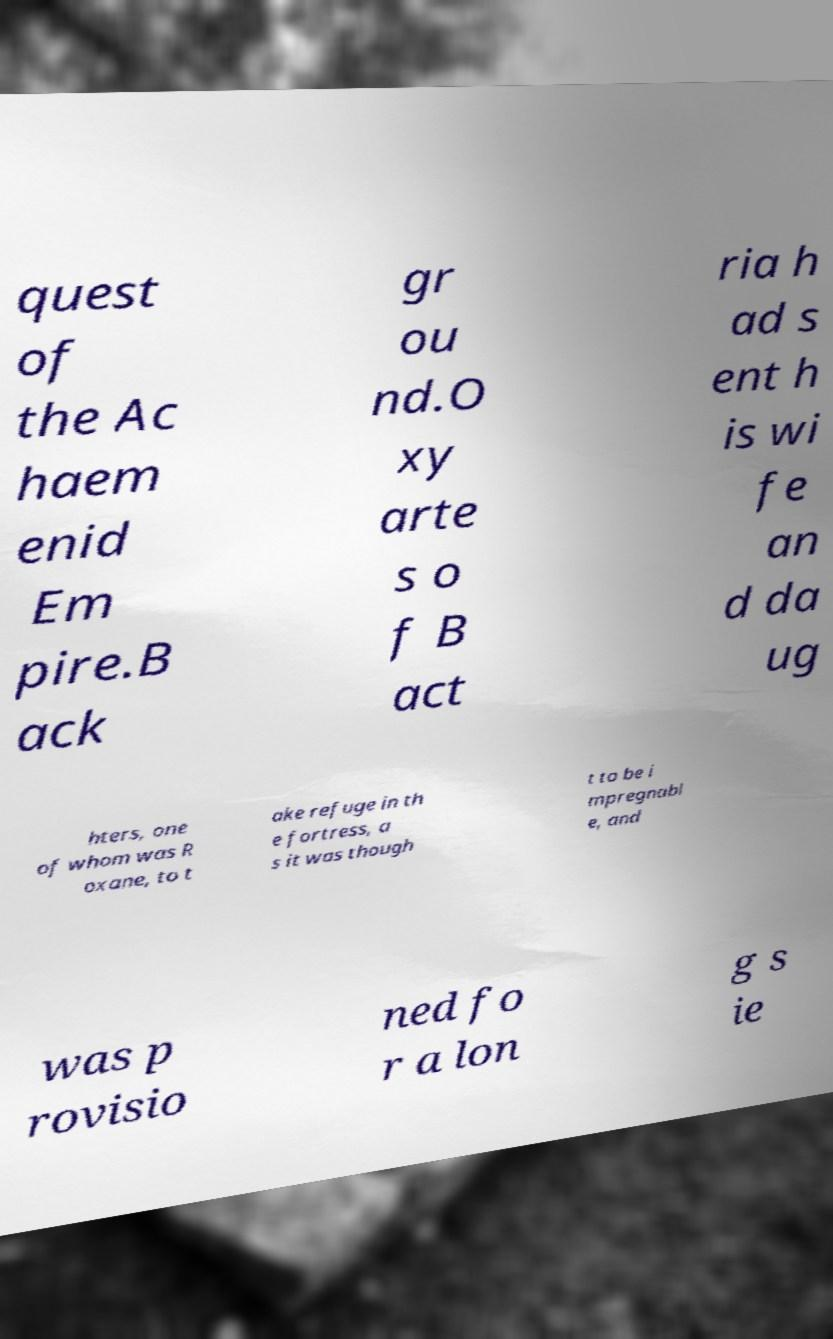Please identify and transcribe the text found in this image. quest of the Ac haem enid Em pire.B ack gr ou nd.O xy arte s o f B act ria h ad s ent h is wi fe an d da ug hters, one of whom was R oxane, to t ake refuge in th e fortress, a s it was though t to be i mpregnabl e, and was p rovisio ned fo r a lon g s ie 